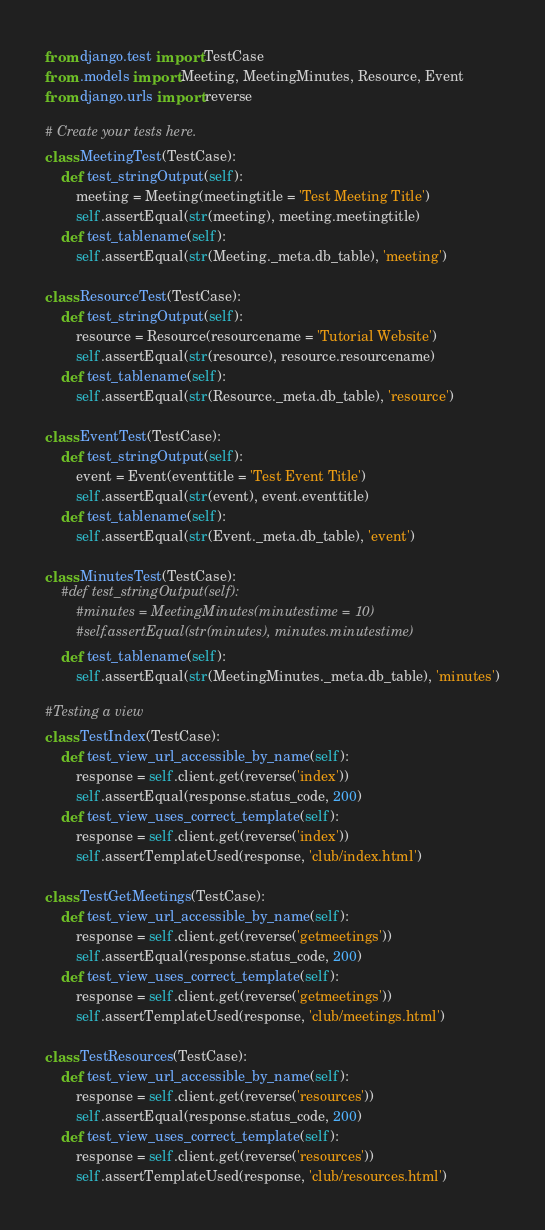<code> <loc_0><loc_0><loc_500><loc_500><_Python_>from django.test import TestCase
from .models import Meeting, MeetingMinutes, Resource, Event
from django.urls import reverse

# Create your tests here.
class MeetingTest(TestCase):
    def test_stringOutput(self):
        meeting = Meeting(meetingtitle = 'Test Meeting Title')
        self.assertEqual(str(meeting), meeting.meetingtitle)
    def test_tablename(self):
        self.assertEqual(str(Meeting._meta.db_table), 'meeting')

class ResourceTest(TestCase):
    def test_stringOutput(self):
        resource = Resource(resourcename = 'Tutorial Website')
        self.assertEqual(str(resource), resource.resourcename)
    def test_tablename(self):
        self.assertEqual(str(Resource._meta.db_table), 'resource')

class EventTest(TestCase):
    def test_stringOutput(self):
        event = Event(eventtitle = 'Test Event Title')
        self.assertEqual(str(event), event.eventtitle)
    def test_tablename(self):
        self.assertEqual(str(Event._meta.db_table), 'event')

class MinutesTest(TestCase):
    #def test_stringOutput(self):
        #minutes = MeetingMinutes(minutestime = 10)
        #self.assertEqual(str(minutes), minutes.minutestime)
    def test_tablename(self):
        self.assertEqual(str(MeetingMinutes._meta.db_table), 'minutes')

#Testing a view
class TestIndex(TestCase):
    def test_view_url_accessible_by_name(self):
        response = self.client.get(reverse('index'))
        self.assertEqual(response.status_code, 200)
    def test_view_uses_correct_template(self):
        response = self.client.get(reverse('index'))
        self.assertTemplateUsed(response, 'club/index.html')

class TestGetMeetings(TestCase):
    def test_view_url_accessible_by_name(self):
        response = self.client.get(reverse('getmeetings'))
        self.assertEqual(response.status_code, 200)
    def test_view_uses_correct_template(self):
        response = self.client.get(reverse('getmeetings'))
        self.assertTemplateUsed(response, 'club/meetings.html')

class TestResources(TestCase):
    def test_view_url_accessible_by_name(self):
        response = self.client.get(reverse('resources'))
        self.assertEqual(response.status_code, 200)
    def test_view_uses_correct_template(self):
        response = self.client.get(reverse('resources'))
        self.assertTemplateUsed(response, 'club/resources.html')</code> 